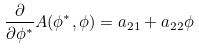<formula> <loc_0><loc_0><loc_500><loc_500>\frac { \partial } { \partial \phi ^ { * } } A ( \phi ^ { * } , \phi ) = a _ { 2 1 } + a _ { 2 2 } \phi</formula> 